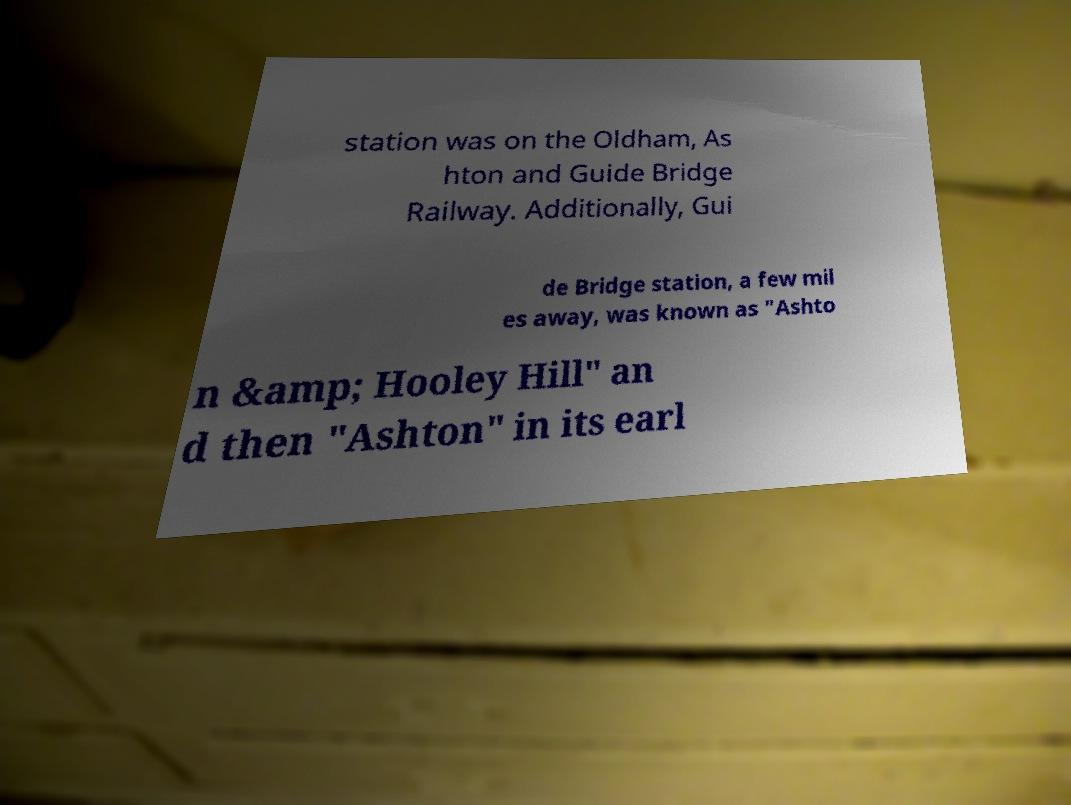I need the written content from this picture converted into text. Can you do that? station was on the Oldham, As hton and Guide Bridge Railway. Additionally, Gui de Bridge station, a few mil es away, was known as "Ashto n &amp; Hooley Hill" an d then "Ashton" in its earl 